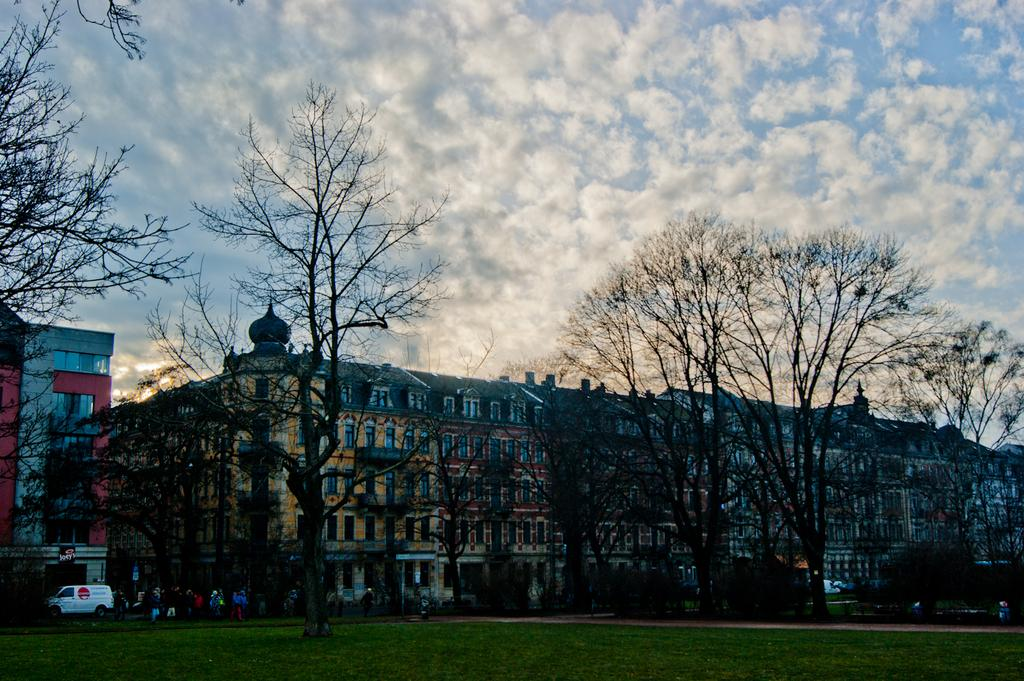What type of natural environment is visible in the image? There is grass in the image, which suggests a natural environment. What type of man-made object can be seen in the image? There is a vehicle in the image. What type of material is present in the image? There are boards in the image. Who or what is present in the image? There are people in the image. What type of vegetation is visible in the image? There are trees in the image. What type of structures are visible in the image? There are buildings in the image. What is visible in the background of the image? The sky is visible in the background of the image, and there are clouds in the sky. Where is the pail located in the image? There is no pail present in the image. What type of dust can be seen in the image? There is no dust visible in the image. 